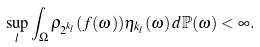<formula> <loc_0><loc_0><loc_500><loc_500>\sup _ { l } \int _ { \Omega } \rho _ { 2 ^ { k _ { l } } } ( f ( \omega ) ) \eta _ { k _ { l } } ( \omega ) \, d \mathbb { P } ( \omega ) < \infty .</formula> 